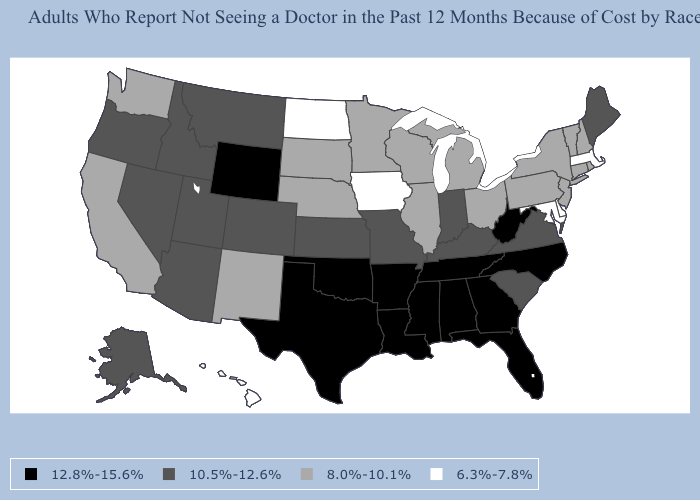Name the states that have a value in the range 12.8%-15.6%?
Give a very brief answer. Alabama, Arkansas, Florida, Georgia, Louisiana, Mississippi, North Carolina, Oklahoma, Tennessee, Texas, West Virginia, Wyoming. Does Delaware have the lowest value in the USA?
Concise answer only. Yes. What is the value of Hawaii?
Answer briefly. 6.3%-7.8%. Name the states that have a value in the range 12.8%-15.6%?
Quick response, please. Alabama, Arkansas, Florida, Georgia, Louisiana, Mississippi, North Carolina, Oklahoma, Tennessee, Texas, West Virginia, Wyoming. Name the states that have a value in the range 8.0%-10.1%?
Write a very short answer. California, Connecticut, Illinois, Michigan, Minnesota, Nebraska, New Hampshire, New Jersey, New Mexico, New York, Ohio, Pennsylvania, Rhode Island, South Dakota, Vermont, Washington, Wisconsin. Does the map have missing data?
Keep it brief. No. Does the map have missing data?
Short answer required. No. What is the value of Kentucky?
Quick response, please. 10.5%-12.6%. What is the highest value in the USA?
Quick response, please. 12.8%-15.6%. Which states have the lowest value in the USA?
Short answer required. Delaware, Hawaii, Iowa, Maryland, Massachusetts, North Dakota. Name the states that have a value in the range 10.5%-12.6%?
Be succinct. Alaska, Arizona, Colorado, Idaho, Indiana, Kansas, Kentucky, Maine, Missouri, Montana, Nevada, Oregon, South Carolina, Utah, Virginia. What is the value of Iowa?
Short answer required. 6.3%-7.8%. What is the value of South Dakota?
Write a very short answer. 8.0%-10.1%. Which states have the lowest value in the USA?
Keep it brief. Delaware, Hawaii, Iowa, Maryland, Massachusetts, North Dakota. Does Wyoming have the highest value in the USA?
Concise answer only. Yes. 